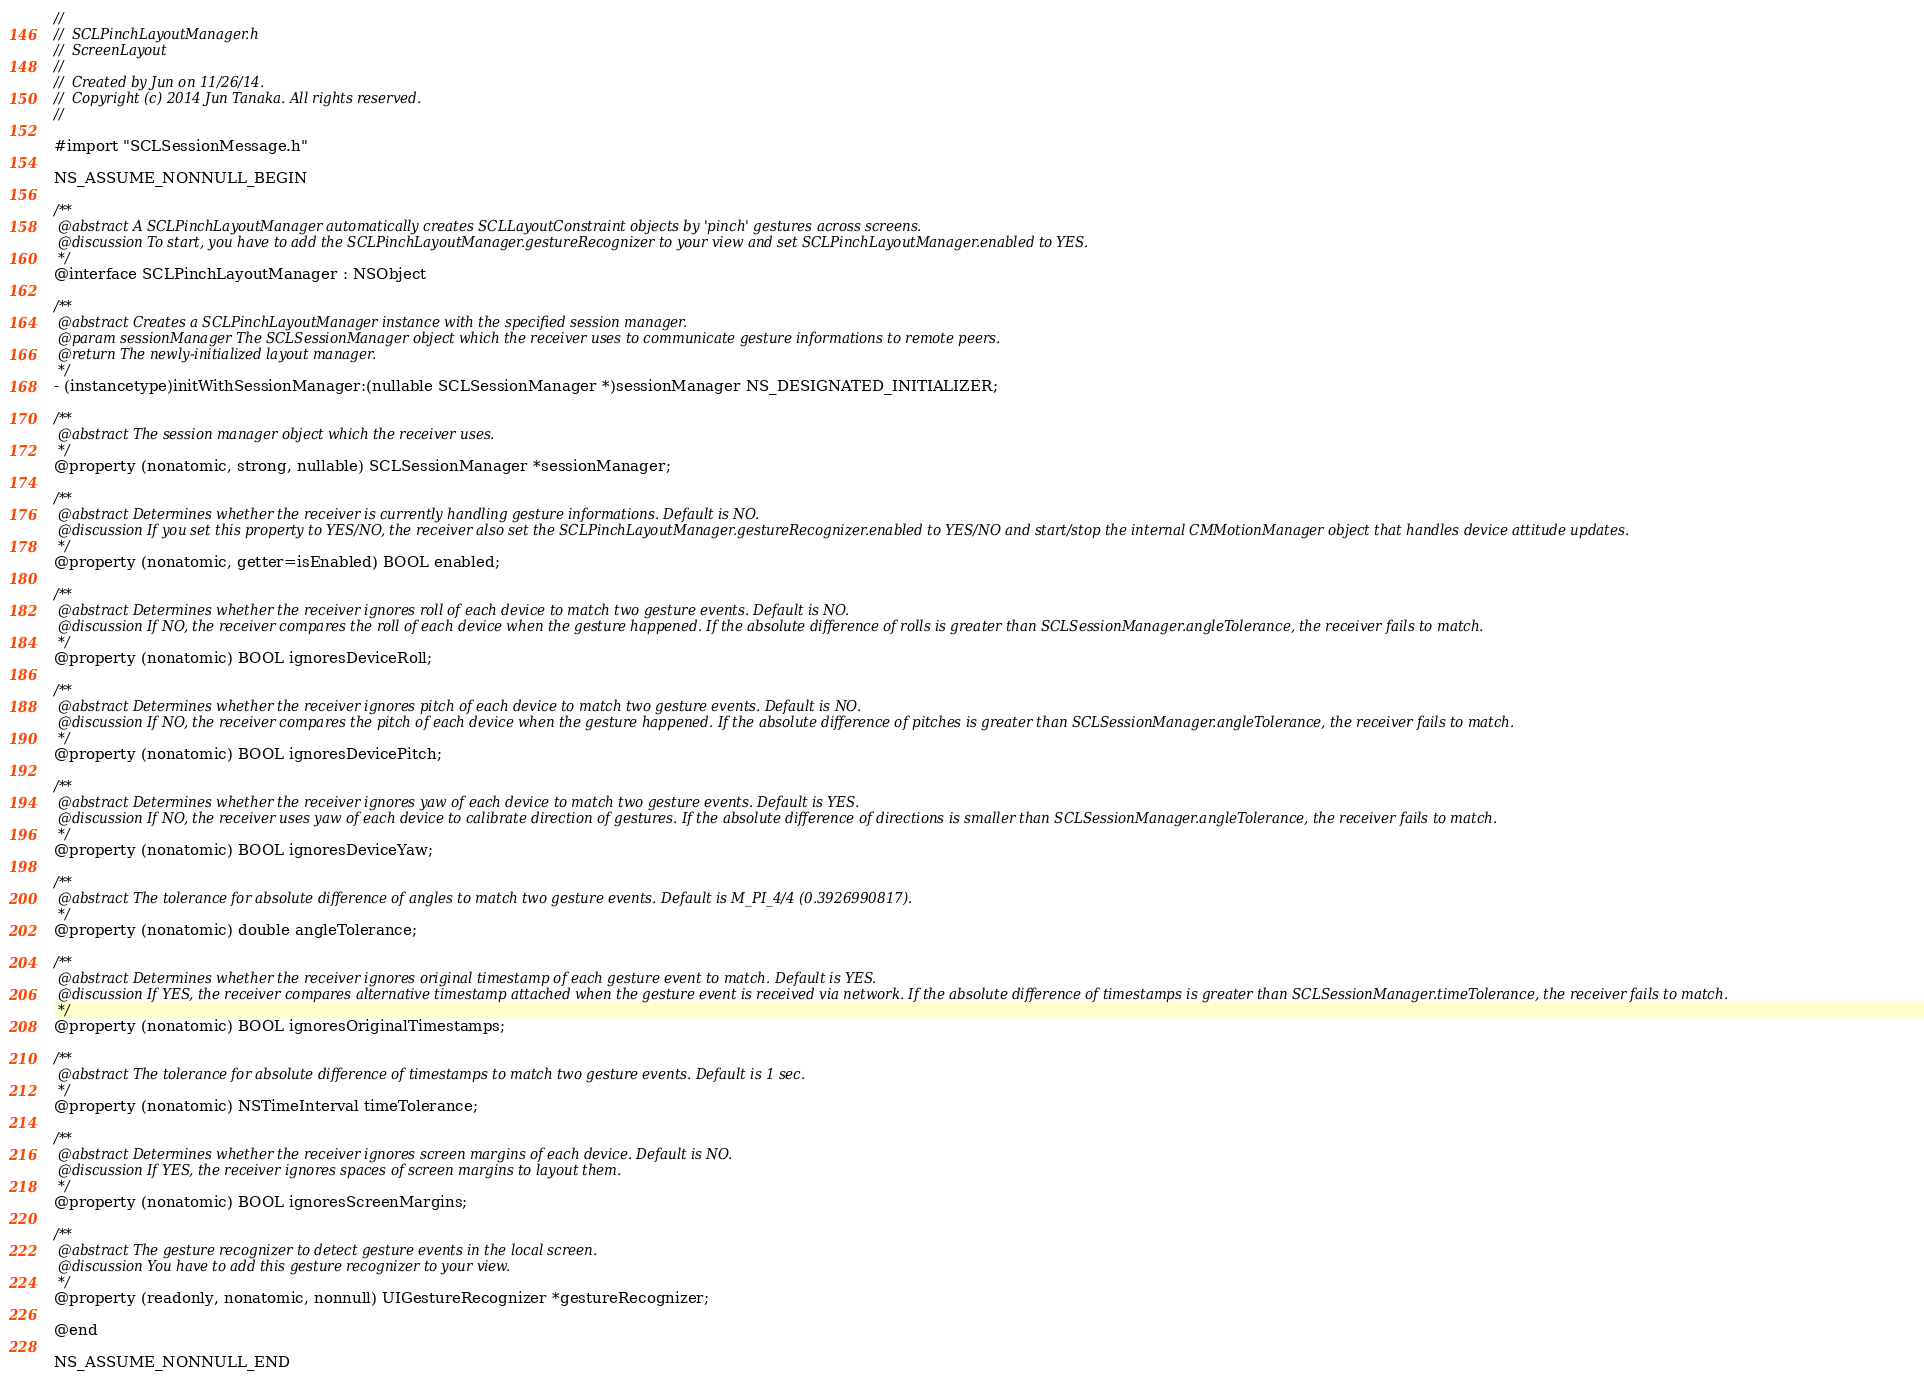Convert code to text. <code><loc_0><loc_0><loc_500><loc_500><_C_>//
//  SCLPinchLayoutManager.h
//  ScreenLayout
//
//  Created by Jun on 11/26/14.
//  Copyright (c) 2014 Jun Tanaka. All rights reserved.
//

#import "SCLSessionMessage.h"

NS_ASSUME_NONNULL_BEGIN

/**
 @abstract A SCLPinchLayoutManager automatically creates SCLLayoutConstraint objects by 'pinch' gestures across screens.
 @discussion To start, you have to add the SCLPinchLayoutManager.gestureRecognizer to your view and set SCLPinchLayoutManager.enabled to YES.
 */
@interface SCLPinchLayoutManager : NSObject

/**
 @abstract Creates a SCLPinchLayoutManager instance with the specified session manager.
 @param sessionManager The SCLSessionManager object which the receiver uses to communicate gesture informations to remote peers.
 @return The newly-initialized layout manager.
 */
- (instancetype)initWithSessionManager:(nullable SCLSessionManager *)sessionManager NS_DESIGNATED_INITIALIZER;

/**
 @abstract The session manager object which the receiver uses.
 */
@property (nonatomic, strong, nullable) SCLSessionManager *sessionManager;

/**
 @abstract Determines whether the receiver is currently handling gesture informations. Default is NO.
 @discussion If you set this property to YES/NO, the receiver also set the SCLPinchLayoutManager.gestureRecognizer.enabled to YES/NO and start/stop the internal CMMotionManager object that handles device attitude updates.
 */
@property (nonatomic, getter=isEnabled) BOOL enabled;

/**
 @abstract Determines whether the receiver ignores roll of each device to match two gesture events. Default is NO.
 @discussion If NO, the receiver compares the roll of each device when the gesture happened. If the absolute difference of rolls is greater than SCLSessionManager.angleTolerance, the receiver fails to match.
 */
@property (nonatomic) BOOL ignoresDeviceRoll;

/**
 @abstract Determines whether the receiver ignores pitch of each device to match two gesture events. Default is NO.
 @discussion If NO, the receiver compares the pitch of each device when the gesture happened. If the absolute difference of pitches is greater than SCLSessionManager.angleTolerance, the receiver fails to match.
 */
@property (nonatomic) BOOL ignoresDevicePitch;

/**
 @abstract Determines whether the receiver ignores yaw of each device to match two gesture events. Default is YES.
 @discussion If NO, the receiver uses yaw of each device to calibrate direction of gestures. If the absolute difference of directions is smaller than SCLSessionManager.angleTolerance, the receiver fails to match.
 */
@property (nonatomic) BOOL ignoresDeviceYaw;

/**
 @abstract The tolerance for absolute difference of angles to match two gesture events. Default is M_PI_4/4 (0.3926990817).
 */
@property (nonatomic) double angleTolerance;

/**
 @abstract Determines whether the receiver ignores original timestamp of each gesture event to match. Default is YES.
 @discussion If YES, the receiver compares alternative timestamp attached when the gesture event is received via network. If the absolute difference of timestamps is greater than SCLSessionManager.timeTolerance, the receiver fails to match.
 */
@property (nonatomic) BOOL ignoresOriginalTimestamps;

/**
 @abstract The tolerance for absolute difference of timestamps to match two gesture events. Default is 1 sec.
 */
@property (nonatomic) NSTimeInterval timeTolerance;

/**
 @abstract Determines whether the receiver ignores screen margins of each device. Default is NO.
 @discussion If YES, the receiver ignores spaces of screen margins to layout them.
 */
@property (nonatomic) BOOL ignoresScreenMargins;

/**
 @abstract The gesture recognizer to detect gesture events in the local screen.
 @discussion You have to add this gesture recognizer to your view.
 */
@property (readonly, nonatomic, nonnull) UIGestureRecognizer *gestureRecognizer;

@end

NS_ASSUME_NONNULL_END
</code> 